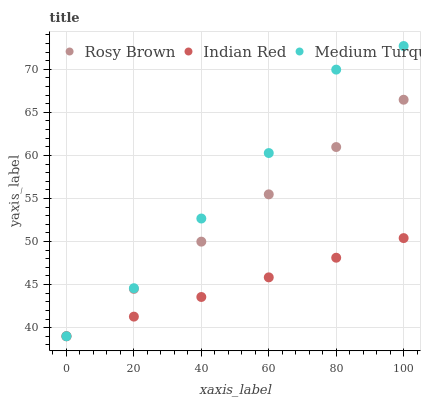Does Indian Red have the minimum area under the curve?
Answer yes or no. Yes. Does Medium Turquoise have the maximum area under the curve?
Answer yes or no. Yes. Does Medium Turquoise have the minimum area under the curve?
Answer yes or no. No. Does Indian Red have the maximum area under the curve?
Answer yes or no. No. Is Rosy Brown the smoothest?
Answer yes or no. Yes. Is Medium Turquoise the roughest?
Answer yes or no. Yes. Is Indian Red the smoothest?
Answer yes or no. No. Is Indian Red the roughest?
Answer yes or no. No. Does Rosy Brown have the lowest value?
Answer yes or no. Yes. Does Medium Turquoise have the highest value?
Answer yes or no. Yes. Does Indian Red have the highest value?
Answer yes or no. No. Does Medium Turquoise intersect Indian Red?
Answer yes or no. Yes. Is Medium Turquoise less than Indian Red?
Answer yes or no. No. Is Medium Turquoise greater than Indian Red?
Answer yes or no. No. 